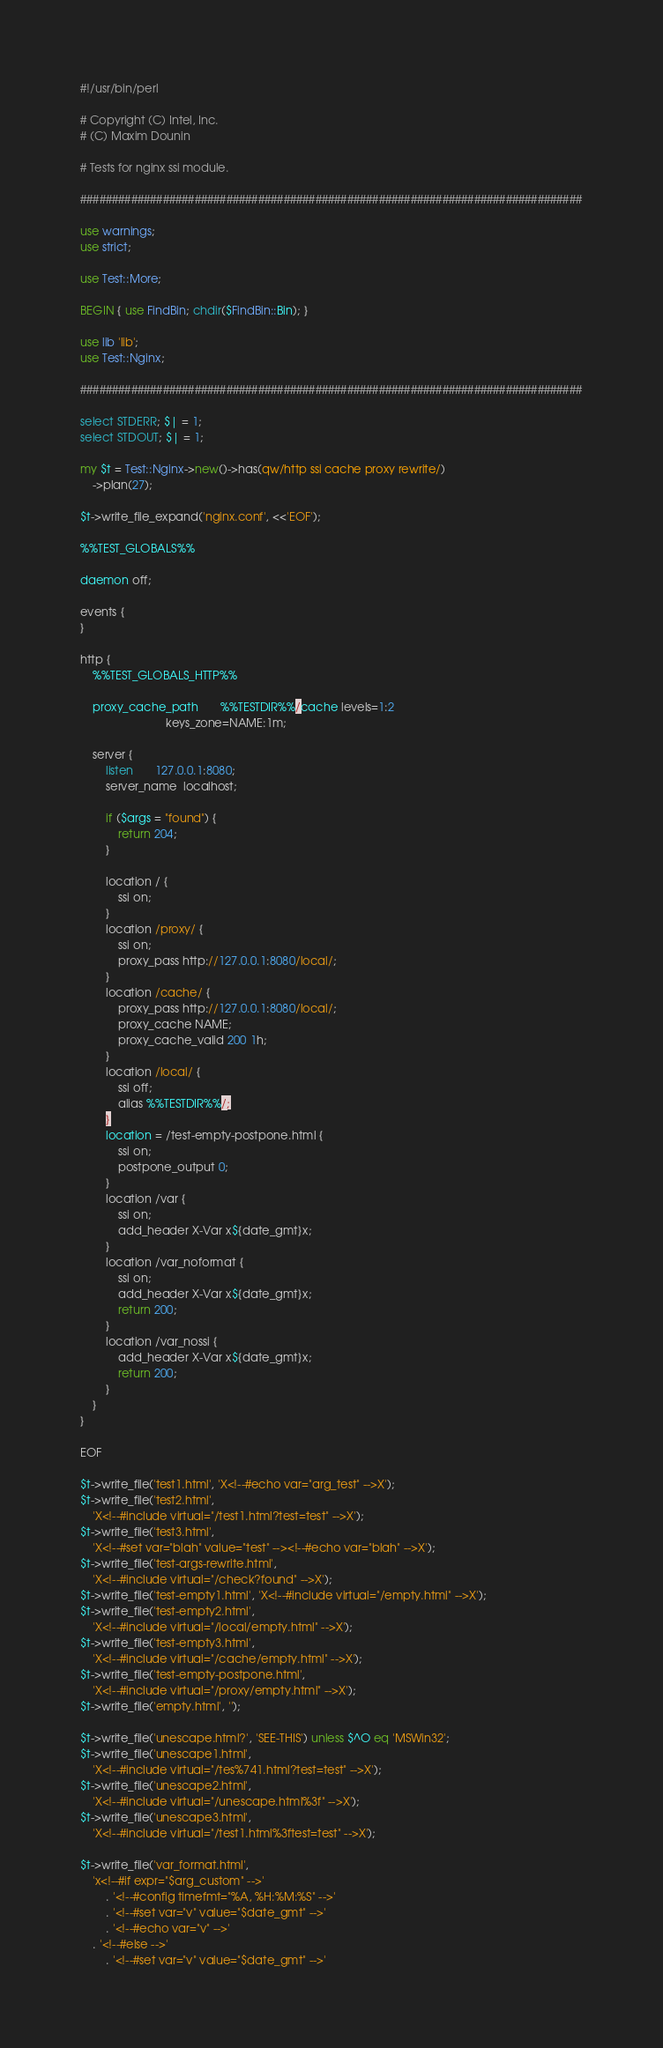<code> <loc_0><loc_0><loc_500><loc_500><_Perl_>#!/usr/bin/perl

# Copyright (C) Intel, Inc.
# (C) Maxim Dounin

# Tests for nginx ssi module.

###############################################################################

use warnings;
use strict;

use Test::More;

BEGIN { use FindBin; chdir($FindBin::Bin); }

use lib 'lib';
use Test::Nginx;

###############################################################################

select STDERR; $| = 1;
select STDOUT; $| = 1;

my $t = Test::Nginx->new()->has(qw/http ssi cache proxy rewrite/)
	->plan(27);

$t->write_file_expand('nginx.conf', <<'EOF');

%%TEST_GLOBALS%%

daemon off;

events {
}

http {
    %%TEST_GLOBALS_HTTP%%

    proxy_cache_path       %%TESTDIR%%/cache levels=1:2
                           keys_zone=NAME:1m;

    server {
        listen       127.0.0.1:8080;
        server_name  localhost;

        if ($args = "found") {
            return 204;
        }

        location / {
            ssi on;
        }
        location /proxy/ {
            ssi on;
            proxy_pass http://127.0.0.1:8080/local/;
        }
        location /cache/ {
            proxy_pass http://127.0.0.1:8080/local/;
            proxy_cache NAME;
            proxy_cache_valid 200 1h;
        }
        location /local/ {
            ssi off;
            alias %%TESTDIR%%/;
        }
        location = /test-empty-postpone.html {
            ssi on;
            postpone_output 0;
        }
        location /var {
            ssi on;
            add_header X-Var x${date_gmt}x;
        }
        location /var_noformat {
            ssi on;
            add_header X-Var x${date_gmt}x;
            return 200;
        }
        location /var_nossi {
            add_header X-Var x${date_gmt}x;
            return 200;
        }
    }
}

EOF

$t->write_file('test1.html', 'X<!--#echo var="arg_test" -->X');
$t->write_file('test2.html',
	'X<!--#include virtual="/test1.html?test=test" -->X');
$t->write_file('test3.html',
	'X<!--#set var="blah" value="test" --><!--#echo var="blah" -->X');
$t->write_file('test-args-rewrite.html',
	'X<!--#include virtual="/check?found" -->X');
$t->write_file('test-empty1.html', 'X<!--#include virtual="/empty.html" -->X');
$t->write_file('test-empty2.html',
	'X<!--#include virtual="/local/empty.html" -->X');
$t->write_file('test-empty3.html',
	'X<!--#include virtual="/cache/empty.html" -->X');
$t->write_file('test-empty-postpone.html',
	'X<!--#include virtual="/proxy/empty.html" -->X');
$t->write_file('empty.html', '');

$t->write_file('unescape.html?', 'SEE-THIS') unless $^O eq 'MSWin32';
$t->write_file('unescape1.html',
	'X<!--#include virtual="/tes%741.html?test=test" -->X');
$t->write_file('unescape2.html',
	'X<!--#include virtual="/unescape.html%3f" -->X');
$t->write_file('unescape3.html',
	'X<!--#include virtual="/test1.html%3ftest=test" -->X');

$t->write_file('var_format.html',
	'x<!--#if expr="$arg_custom" -->'
		. '<!--#config timefmt="%A, %H:%M:%S" -->'
		. '<!--#set var="v" value="$date_gmt" -->'
		. '<!--#echo var="v" -->'
	. '<!--#else -->'
		. '<!--#set var="v" value="$date_gmt" -->'</code> 